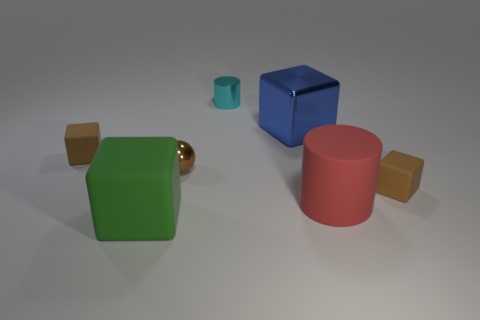Is there any other thing that has the same shape as the big blue shiny object?
Provide a short and direct response. Yes. There is a rubber thing that is the same shape as the cyan metallic object; what is its color?
Ensure brevity in your answer.  Red. What is the color of the cube that is made of the same material as the tiny brown ball?
Provide a succinct answer. Blue. Are there an equal number of tiny rubber cubes in front of the big rubber cylinder and small balls?
Offer a terse response. No. Does the brown rubber object left of the brown metallic thing have the same size as the big blue metallic thing?
Offer a terse response. No. There is a matte block that is the same size as the rubber cylinder; what color is it?
Provide a succinct answer. Green. There is a thing that is left of the matte thing in front of the big red object; are there any large blue blocks to the left of it?
Your answer should be very brief. No. What is the tiny brown block to the left of the big blue shiny object made of?
Offer a terse response. Rubber. There is a tiny cyan shiny object; is it the same shape as the big rubber thing to the right of the tiny metal ball?
Your answer should be very brief. Yes. Is the number of big red things that are on the left side of the large blue block the same as the number of cyan cylinders on the left side of the brown metallic object?
Your answer should be compact. Yes. 